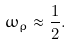Convert formula to latex. <formula><loc_0><loc_0><loc_500><loc_500>\omega _ { \rho } \approx \frac { 1 } { 2 } .</formula> 